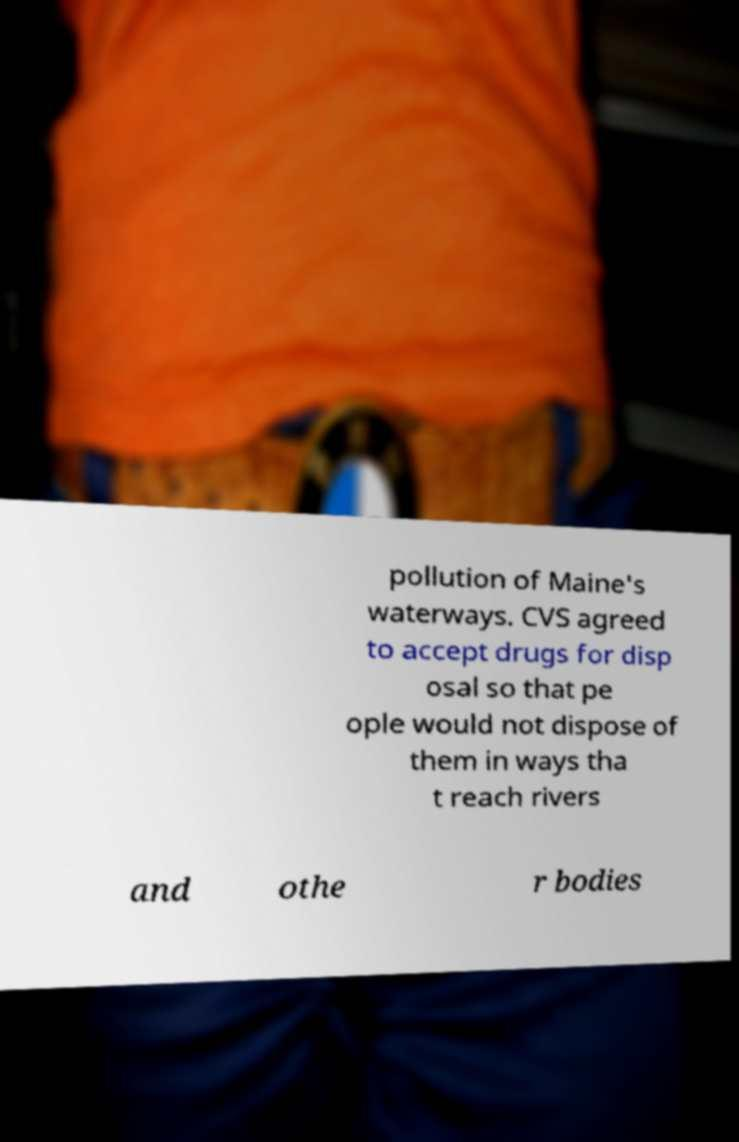What messages or text are displayed in this image? I need them in a readable, typed format. pollution of Maine's waterways. CVS agreed to accept drugs for disp osal so that pe ople would not dispose of them in ways tha t reach rivers and othe r bodies 